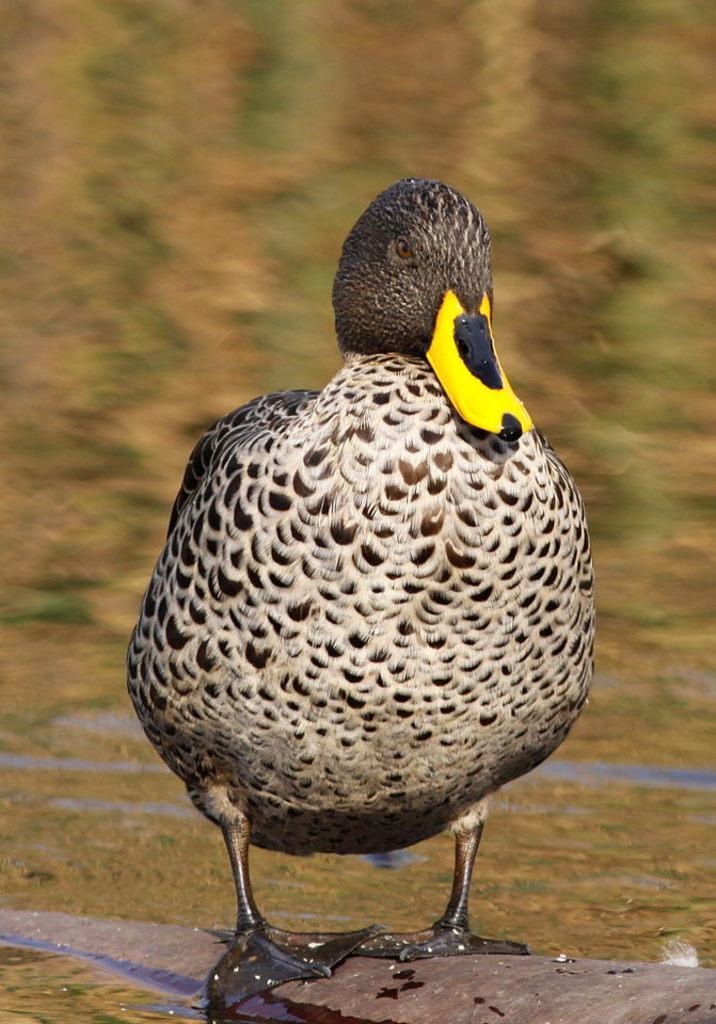How would you summarize this image in a sentence or two? In this image I can see a duck is standing in the front. I can see colour of this duck is white and black. I can also see this image is blurry in the background. 